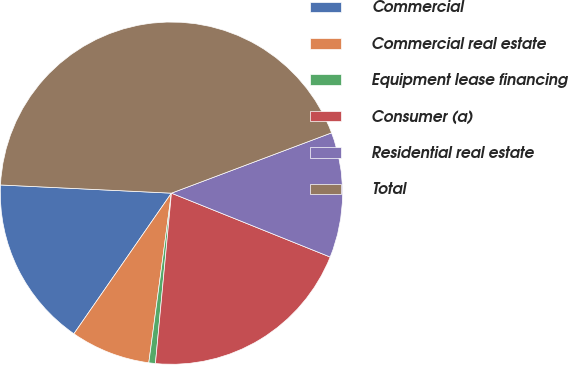Convert chart. <chart><loc_0><loc_0><loc_500><loc_500><pie_chart><fcel>Commercial<fcel>Commercial real estate<fcel>Equipment lease financing<fcel>Consumer (a)<fcel>Residential real estate<fcel>Total<nl><fcel>16.11%<fcel>7.54%<fcel>0.62%<fcel>20.4%<fcel>11.82%<fcel>43.5%<nl></chart> 